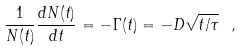Convert formula to latex. <formula><loc_0><loc_0><loc_500><loc_500>\frac { 1 } { N ( t ) } \frac { d N ( t ) } { d t } = - \Gamma ( t ) = - D \sqrt { t / \tau } \ ,</formula> 